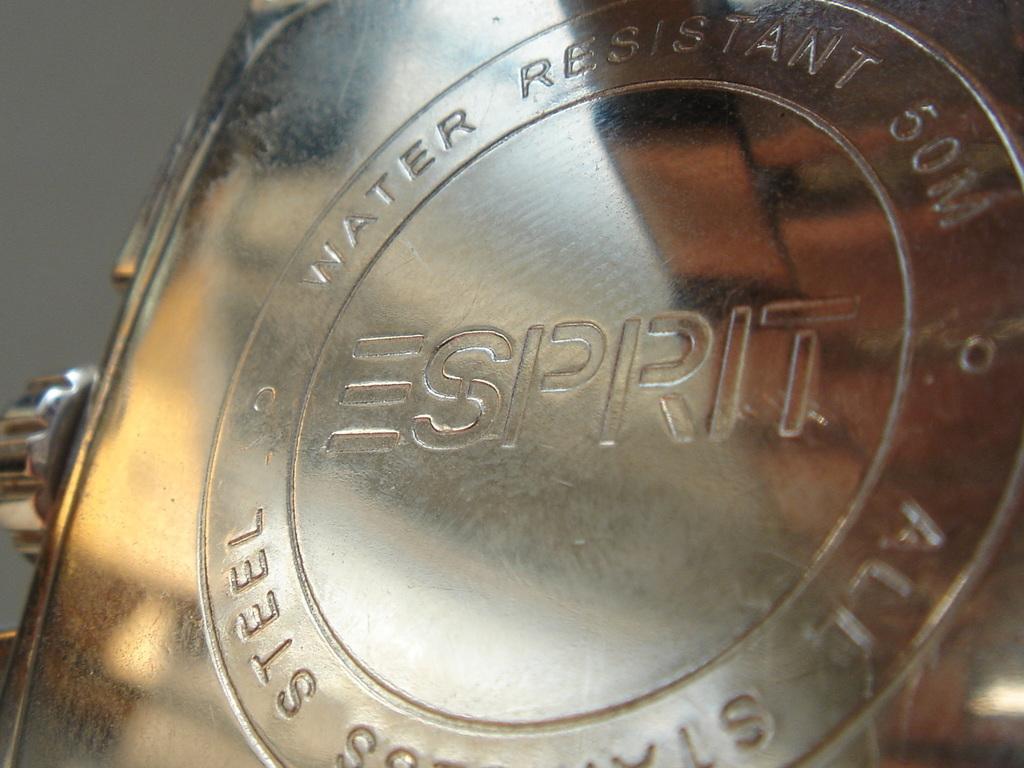Is this water resistant?
Give a very brief answer. Yes. In what word it is typing?
Your answer should be compact. Esprit. 